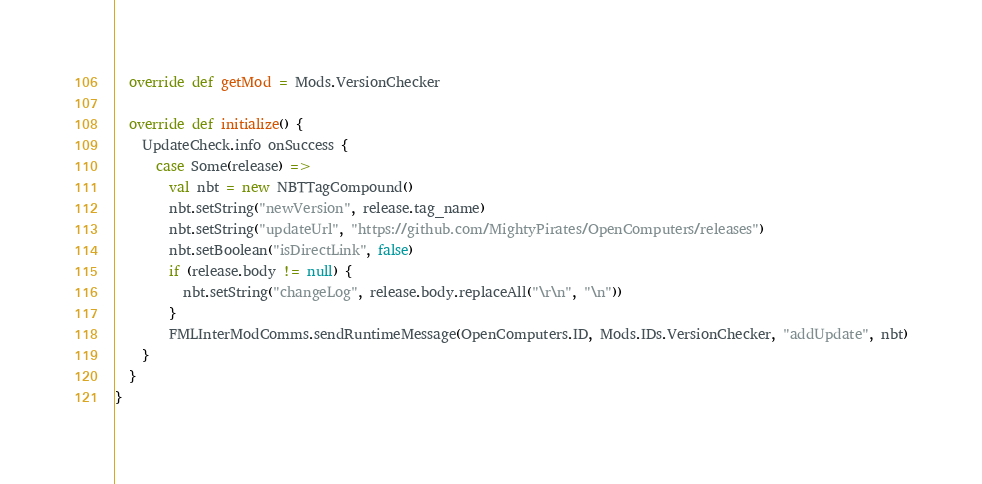<code> <loc_0><loc_0><loc_500><loc_500><_Scala_>  override def getMod = Mods.VersionChecker

  override def initialize() {
    UpdateCheck.info onSuccess {
      case Some(release) =>
        val nbt = new NBTTagCompound()
        nbt.setString("newVersion", release.tag_name)
        nbt.setString("updateUrl", "https://github.com/MightyPirates/OpenComputers/releases")
        nbt.setBoolean("isDirectLink", false)
        if (release.body != null) {
          nbt.setString("changeLog", release.body.replaceAll("\r\n", "\n"))
        }
        FMLInterModComms.sendRuntimeMessage(OpenComputers.ID, Mods.IDs.VersionChecker, "addUpdate", nbt)
    }
  }
}
</code> 